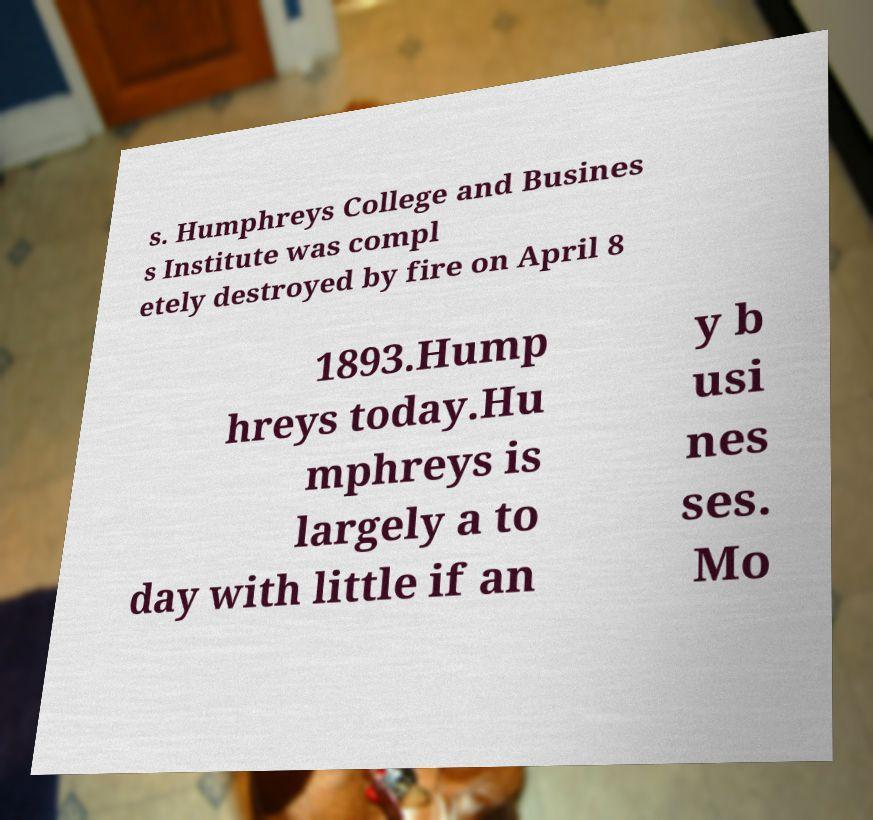I need the written content from this picture converted into text. Can you do that? s. Humphreys College and Busines s Institute was compl etely destroyed by fire on April 8 1893.Hump hreys today.Hu mphreys is largely a to day with little if an y b usi nes ses. Mo 